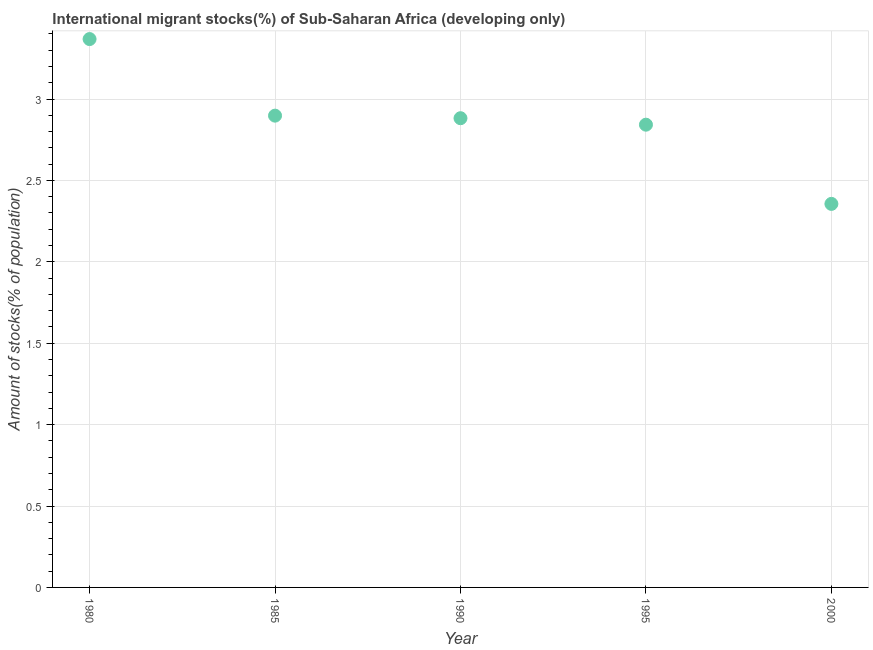What is the number of international migrant stocks in 1990?
Your answer should be compact. 2.88. Across all years, what is the maximum number of international migrant stocks?
Provide a short and direct response. 3.37. Across all years, what is the minimum number of international migrant stocks?
Your answer should be very brief. 2.36. In which year was the number of international migrant stocks minimum?
Provide a short and direct response. 2000. What is the sum of the number of international migrant stocks?
Your answer should be compact. 14.35. What is the difference between the number of international migrant stocks in 1985 and 1995?
Keep it short and to the point. 0.06. What is the average number of international migrant stocks per year?
Ensure brevity in your answer.  2.87. What is the median number of international migrant stocks?
Ensure brevity in your answer.  2.88. What is the ratio of the number of international migrant stocks in 1990 to that in 2000?
Your answer should be very brief. 1.22. Is the difference between the number of international migrant stocks in 1980 and 2000 greater than the difference between any two years?
Provide a succinct answer. Yes. What is the difference between the highest and the second highest number of international migrant stocks?
Keep it short and to the point. 0.47. Is the sum of the number of international migrant stocks in 1980 and 2000 greater than the maximum number of international migrant stocks across all years?
Make the answer very short. Yes. What is the difference between the highest and the lowest number of international migrant stocks?
Provide a short and direct response. 1.01. How many dotlines are there?
Your answer should be compact. 1. How many years are there in the graph?
Provide a succinct answer. 5. Are the values on the major ticks of Y-axis written in scientific E-notation?
Ensure brevity in your answer.  No. What is the title of the graph?
Offer a very short reply. International migrant stocks(%) of Sub-Saharan Africa (developing only). What is the label or title of the X-axis?
Offer a very short reply. Year. What is the label or title of the Y-axis?
Provide a succinct answer. Amount of stocks(% of population). What is the Amount of stocks(% of population) in 1980?
Ensure brevity in your answer.  3.37. What is the Amount of stocks(% of population) in 1985?
Provide a succinct answer. 2.9. What is the Amount of stocks(% of population) in 1990?
Provide a short and direct response. 2.88. What is the Amount of stocks(% of population) in 1995?
Offer a terse response. 2.84. What is the Amount of stocks(% of population) in 2000?
Offer a terse response. 2.36. What is the difference between the Amount of stocks(% of population) in 1980 and 1985?
Keep it short and to the point. 0.47. What is the difference between the Amount of stocks(% of population) in 1980 and 1990?
Give a very brief answer. 0.49. What is the difference between the Amount of stocks(% of population) in 1980 and 1995?
Keep it short and to the point. 0.53. What is the difference between the Amount of stocks(% of population) in 1980 and 2000?
Provide a succinct answer. 1.01. What is the difference between the Amount of stocks(% of population) in 1985 and 1990?
Provide a short and direct response. 0.02. What is the difference between the Amount of stocks(% of population) in 1985 and 1995?
Make the answer very short. 0.06. What is the difference between the Amount of stocks(% of population) in 1985 and 2000?
Provide a succinct answer. 0.54. What is the difference between the Amount of stocks(% of population) in 1990 and 1995?
Ensure brevity in your answer.  0.04. What is the difference between the Amount of stocks(% of population) in 1990 and 2000?
Provide a short and direct response. 0.53. What is the difference between the Amount of stocks(% of population) in 1995 and 2000?
Ensure brevity in your answer.  0.49. What is the ratio of the Amount of stocks(% of population) in 1980 to that in 1985?
Give a very brief answer. 1.16. What is the ratio of the Amount of stocks(% of population) in 1980 to that in 1990?
Make the answer very short. 1.17. What is the ratio of the Amount of stocks(% of population) in 1980 to that in 1995?
Provide a succinct answer. 1.19. What is the ratio of the Amount of stocks(% of population) in 1980 to that in 2000?
Your response must be concise. 1.43. What is the ratio of the Amount of stocks(% of population) in 1985 to that in 1995?
Make the answer very short. 1.02. What is the ratio of the Amount of stocks(% of population) in 1985 to that in 2000?
Keep it short and to the point. 1.23. What is the ratio of the Amount of stocks(% of population) in 1990 to that in 2000?
Provide a short and direct response. 1.22. What is the ratio of the Amount of stocks(% of population) in 1995 to that in 2000?
Your answer should be very brief. 1.21. 